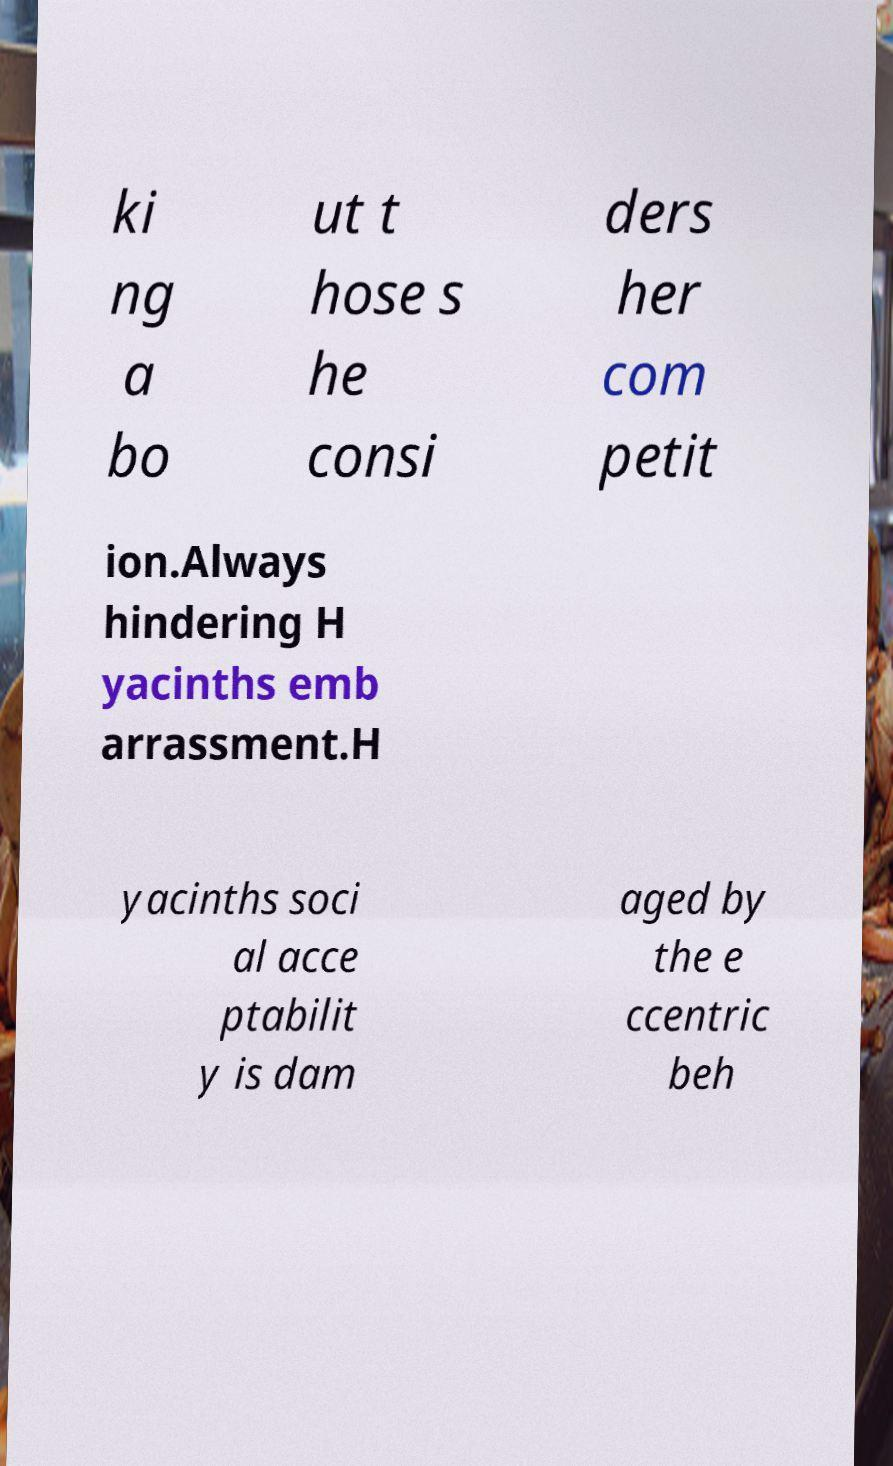Could you extract and type out the text from this image? ki ng a bo ut t hose s he consi ders her com petit ion.Always hindering H yacinths emb arrassment.H yacinths soci al acce ptabilit y is dam aged by the e ccentric beh 